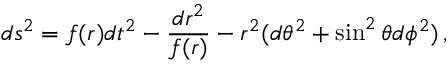<formula> <loc_0><loc_0><loc_500><loc_500>d s ^ { 2 } = f ( r ) d t ^ { 2 } - \frac { d r ^ { 2 } } { f ( r ) } - r ^ { 2 } ( d \theta ^ { 2 } + \sin ^ { 2 } \theta d \phi ^ { 2 } ) \, ,</formula> 